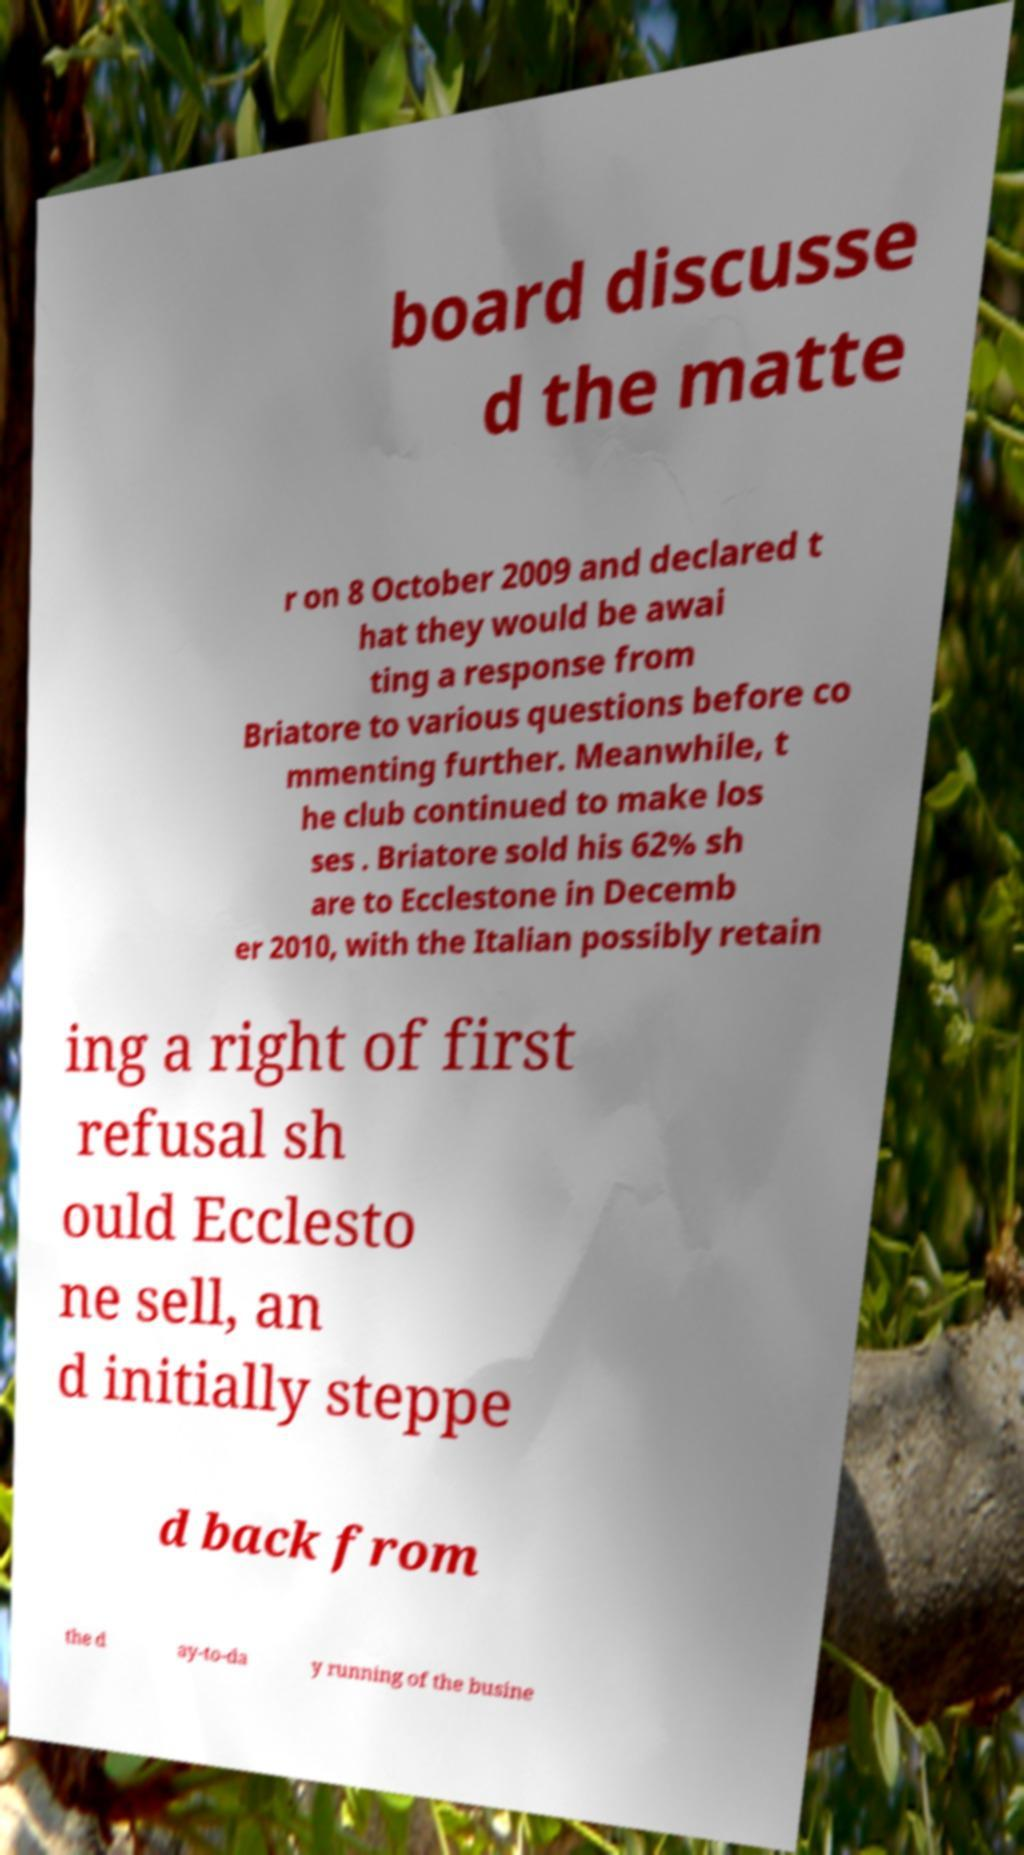There's text embedded in this image that I need extracted. Can you transcribe it verbatim? board discusse d the matte r on 8 October 2009 and declared t hat they would be awai ting a response from Briatore to various questions before co mmenting further. Meanwhile, t he club continued to make los ses . Briatore sold his 62% sh are to Ecclestone in Decemb er 2010, with the Italian possibly retain ing a right of first refusal sh ould Ecclesto ne sell, an d initially steppe d back from the d ay-to-da y running of the busine 